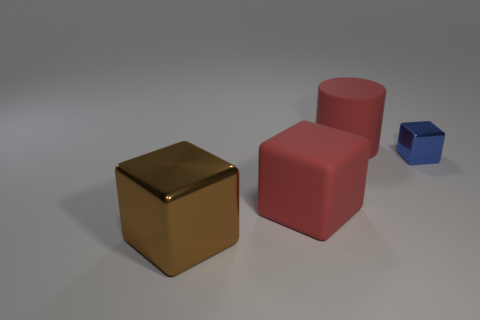Is there any other thing that has the same size as the blue shiny block?
Your answer should be very brief. No. What material is the object that is right of the big red matte cube and in front of the red cylinder?
Offer a very short reply. Metal. What color is the big shiny block?
Offer a very short reply. Brown. Is the number of red matte objects in front of the large cylinder greater than the number of matte things in front of the big metallic block?
Make the answer very short. Yes. There is a metallic thing in front of the tiny blue cube; what is its color?
Offer a very short reply. Brown. There is a metallic thing that is left of the small block; is it the same size as the cube that is to the right of the cylinder?
Offer a very short reply. No. What number of objects are yellow balls or tiny blue objects?
Your answer should be compact. 1. There is a big object behind the large red rubber block in front of the tiny blue metal object; what is its material?
Keep it short and to the point. Rubber. What number of other objects are the same shape as the blue thing?
Give a very brief answer. 2. Are there any rubber blocks that have the same color as the matte cylinder?
Your response must be concise. Yes. 